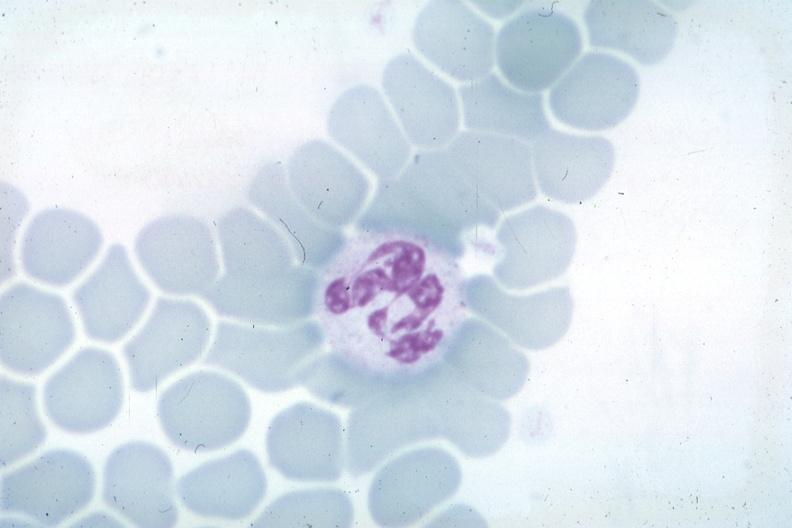s hypersegmented neutrophil present?
Answer the question using a single word or phrase. Yes 